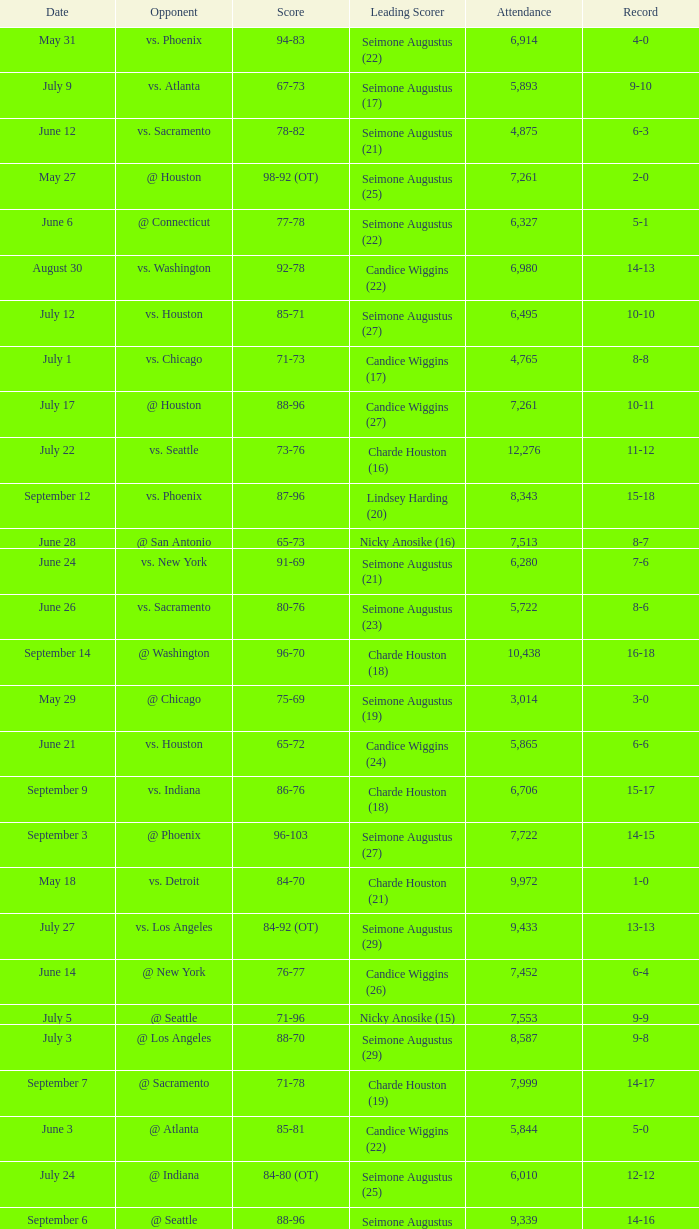Which Leading Scorer has an Opponent of @ seattle, and a Record of 14-16? Seimone Augustus (26). 